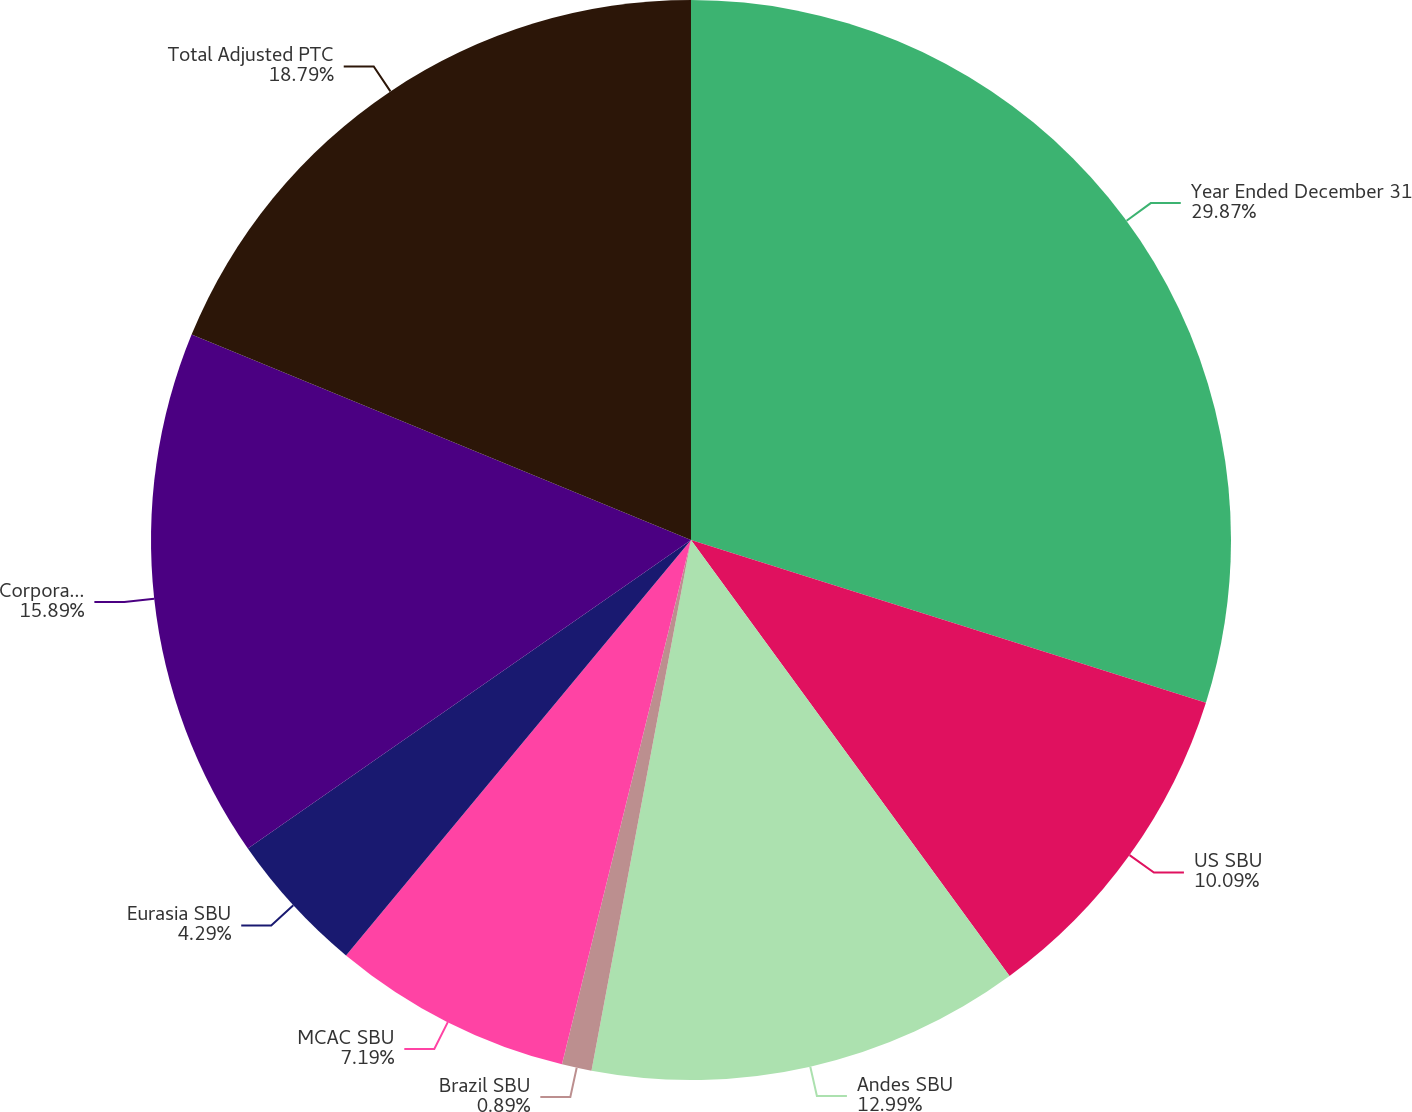Convert chart. <chart><loc_0><loc_0><loc_500><loc_500><pie_chart><fcel>Year Ended December 31<fcel>US SBU<fcel>Andes SBU<fcel>Brazil SBU<fcel>MCAC SBU<fcel>Eurasia SBU<fcel>Corporate and Other<fcel>Total Adjusted PTC<nl><fcel>29.87%<fcel>10.09%<fcel>12.99%<fcel>0.89%<fcel>7.19%<fcel>4.29%<fcel>15.89%<fcel>18.79%<nl></chart> 